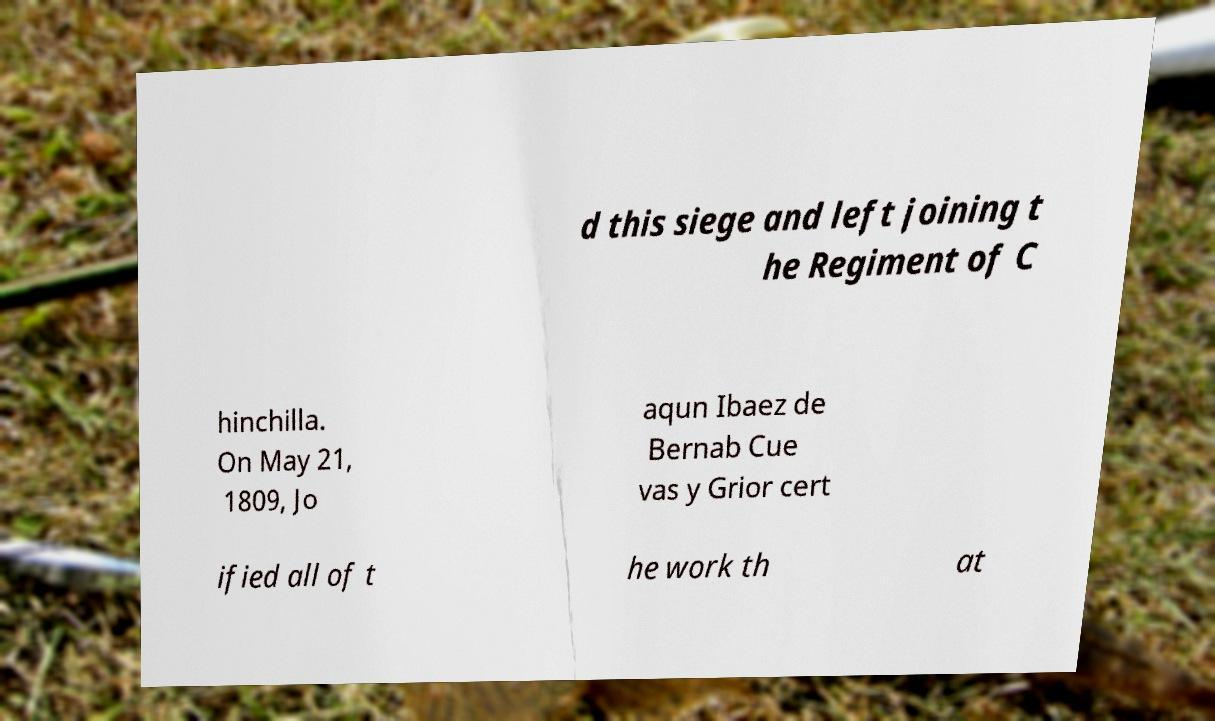What messages or text are displayed in this image? I need them in a readable, typed format. d this siege and left joining t he Regiment of C hinchilla. On May 21, 1809, Jo aqun Ibaez de Bernab Cue vas y Grior cert ified all of t he work th at 